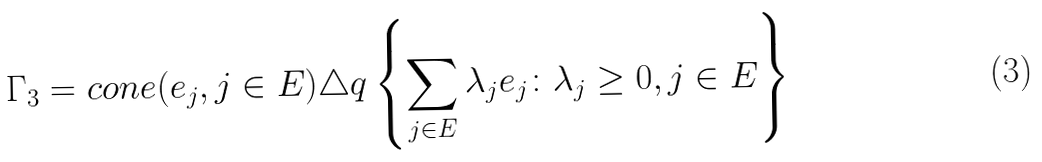Convert formula to latex. <formula><loc_0><loc_0><loc_500><loc_500>\Gamma _ { 3 } = c o n e ( e _ { j } , j \in E ) & \triangle q \left \{ \sum _ { j \in E } \lambda _ { j } e _ { j } \colon \lambda _ { j } \geq 0 , j \in E \right \}</formula> 